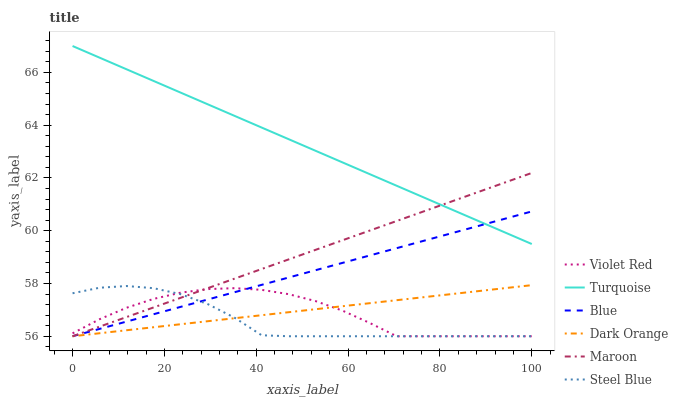Does Steel Blue have the minimum area under the curve?
Answer yes or no. Yes. Does Turquoise have the maximum area under the curve?
Answer yes or no. Yes. Does Dark Orange have the minimum area under the curve?
Answer yes or no. No. Does Dark Orange have the maximum area under the curve?
Answer yes or no. No. Is Blue the smoothest?
Answer yes or no. Yes. Is Violet Red the roughest?
Answer yes or no. Yes. Is Dark Orange the smoothest?
Answer yes or no. No. Is Dark Orange the roughest?
Answer yes or no. No. Does Blue have the lowest value?
Answer yes or no. Yes. Does Turquoise have the lowest value?
Answer yes or no. No. Does Turquoise have the highest value?
Answer yes or no. Yes. Does Dark Orange have the highest value?
Answer yes or no. No. Is Steel Blue less than Turquoise?
Answer yes or no. Yes. Is Turquoise greater than Violet Red?
Answer yes or no. Yes. Does Dark Orange intersect Violet Red?
Answer yes or no. Yes. Is Dark Orange less than Violet Red?
Answer yes or no. No. Is Dark Orange greater than Violet Red?
Answer yes or no. No. Does Steel Blue intersect Turquoise?
Answer yes or no. No. 